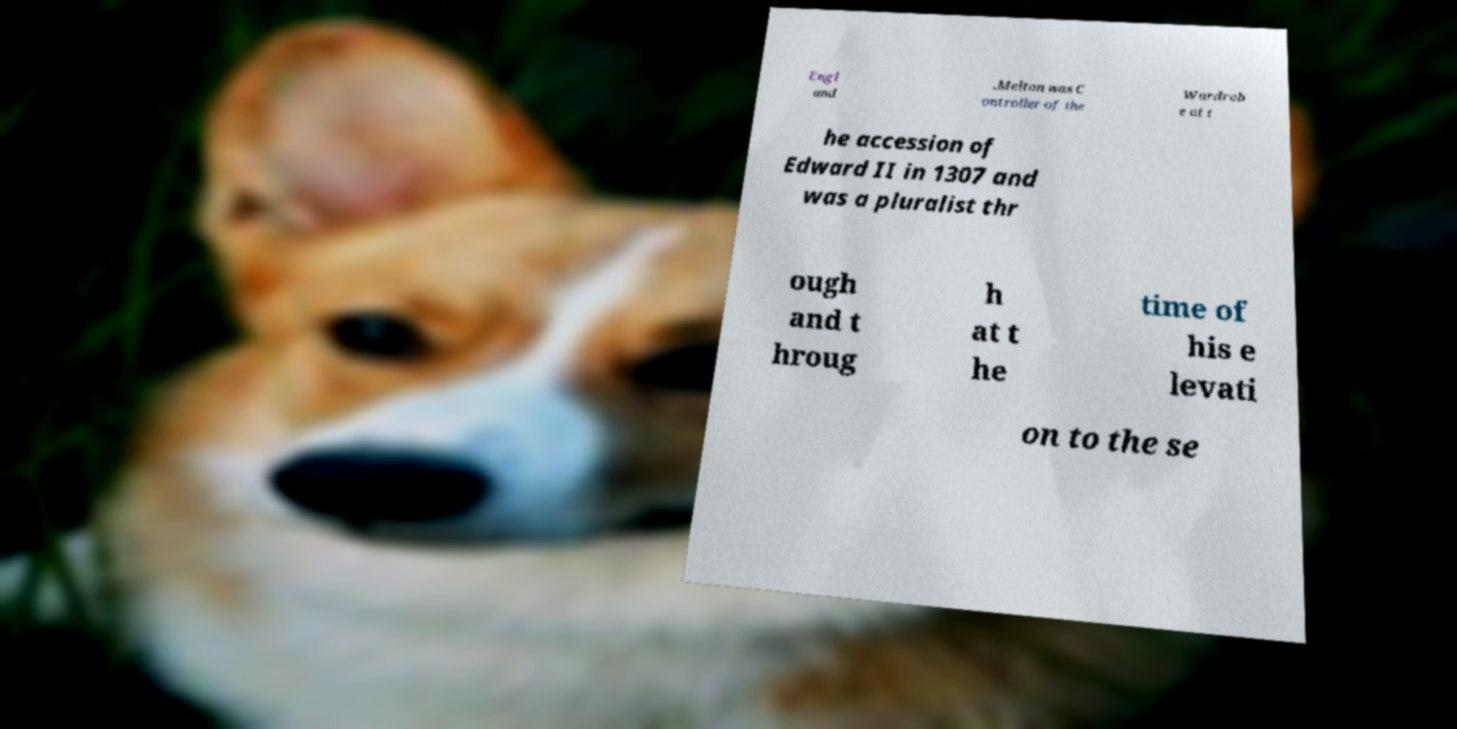I need the written content from this picture converted into text. Can you do that? Engl and .Melton was C ontroller of the Wardrob e at t he accession of Edward II in 1307 and was a pluralist thr ough and t hroug h at t he time of his e levati on to the se 